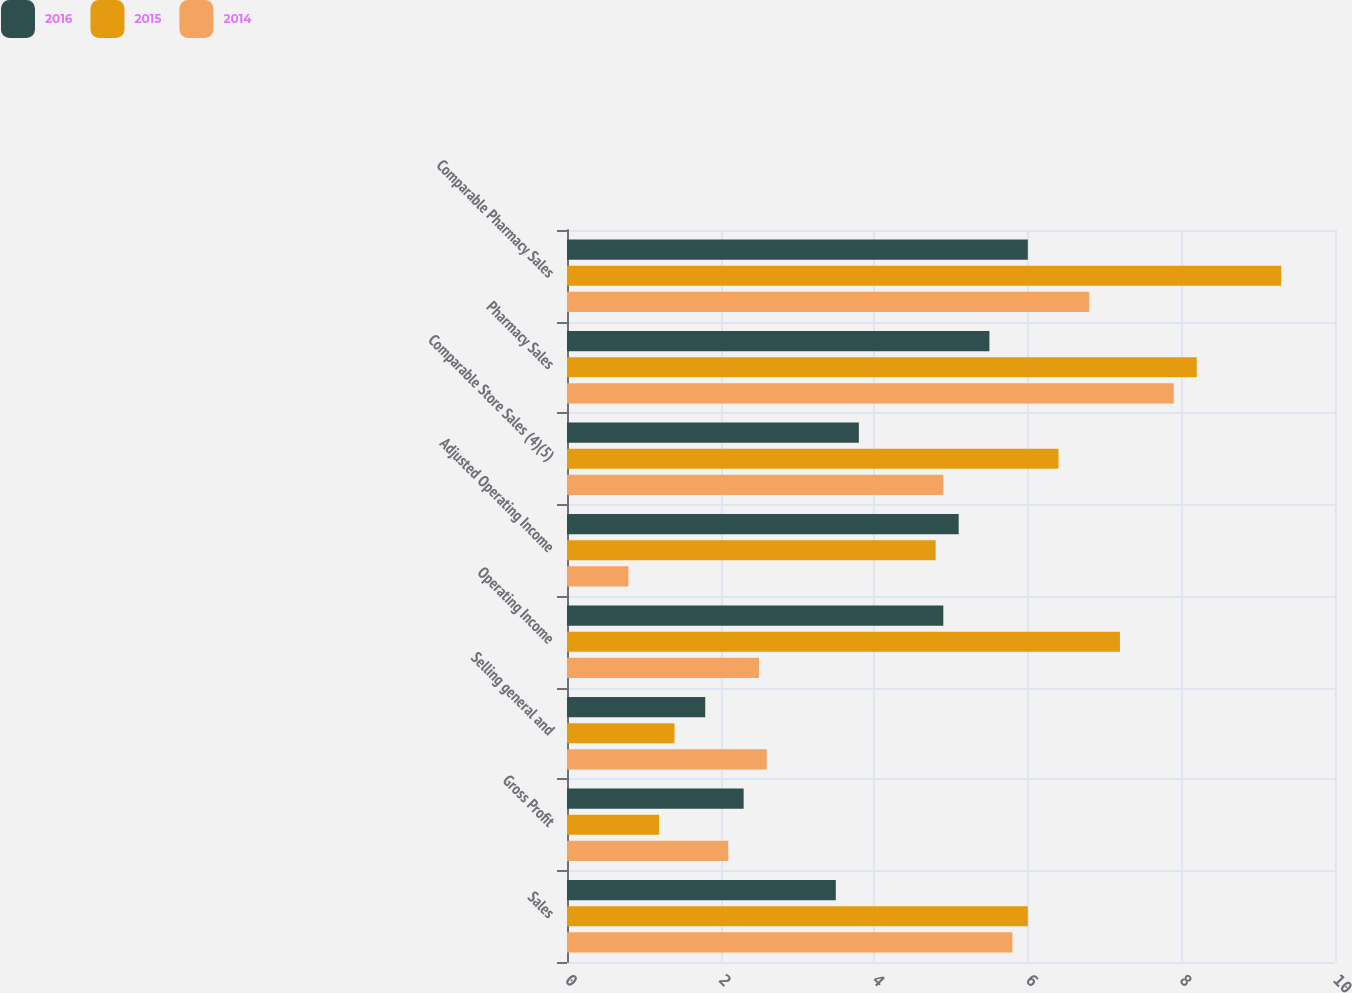Convert chart to OTSL. <chart><loc_0><loc_0><loc_500><loc_500><stacked_bar_chart><ecel><fcel>Sales<fcel>Gross Profit<fcel>Selling general and<fcel>Operating Income<fcel>Adjusted Operating Income<fcel>Comparable Store Sales (4)(5)<fcel>Pharmacy Sales<fcel>Comparable Pharmacy Sales<nl><fcel>2016<fcel>3.5<fcel>2.3<fcel>1.8<fcel>4.9<fcel>5.1<fcel>3.8<fcel>5.5<fcel>6<nl><fcel>2015<fcel>6<fcel>1.2<fcel>1.4<fcel>7.2<fcel>4.8<fcel>6.4<fcel>8.2<fcel>9.3<nl><fcel>2014<fcel>5.8<fcel>2.1<fcel>2.6<fcel>2.5<fcel>0.8<fcel>4.9<fcel>7.9<fcel>6.8<nl></chart> 